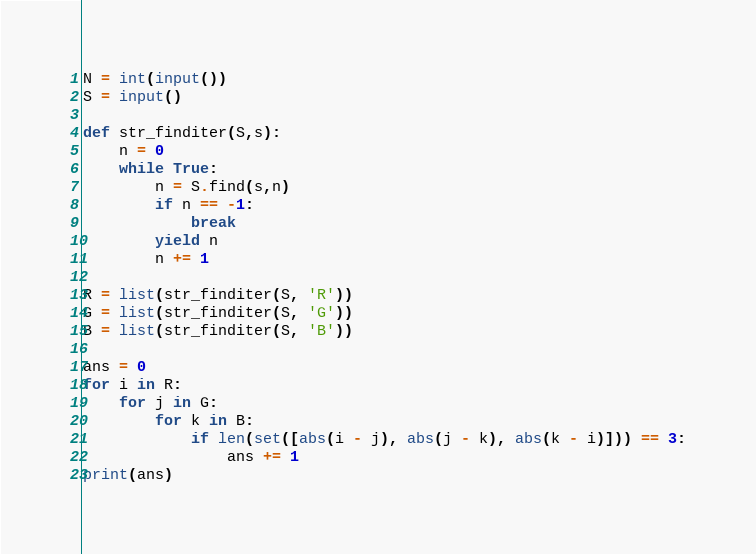Convert code to text. <code><loc_0><loc_0><loc_500><loc_500><_Python_>N = int(input())
S = input()

def str_finditer(S,s):
    n = 0
    while True:
        n = S.find(s,n)
        if n == -1:
            break
        yield n
        n += 1

R = list(str_finditer(S, 'R'))
G = list(str_finditer(S, 'G'))
B = list(str_finditer(S, 'B'))

ans = 0
for i in R:
    for j in G:
        for k in B:
            if len(set([abs(i - j), abs(j - k), abs(k - i)])) == 3:
                ans += 1
print(ans)</code> 